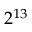Convert formula to latex. <formula><loc_0><loc_0><loc_500><loc_500>2 ^ { 1 3 }</formula> 